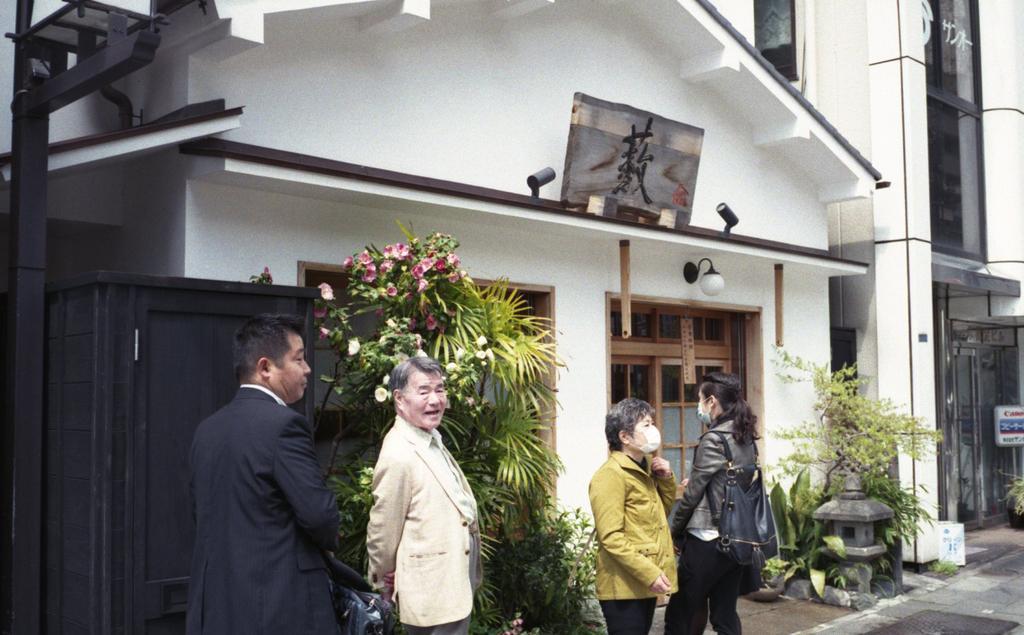How would you summarize this image in a sentence or two? There are four persons standing on the floor. Here we can see plants, flowers, and boards. In the background there are buildings. 